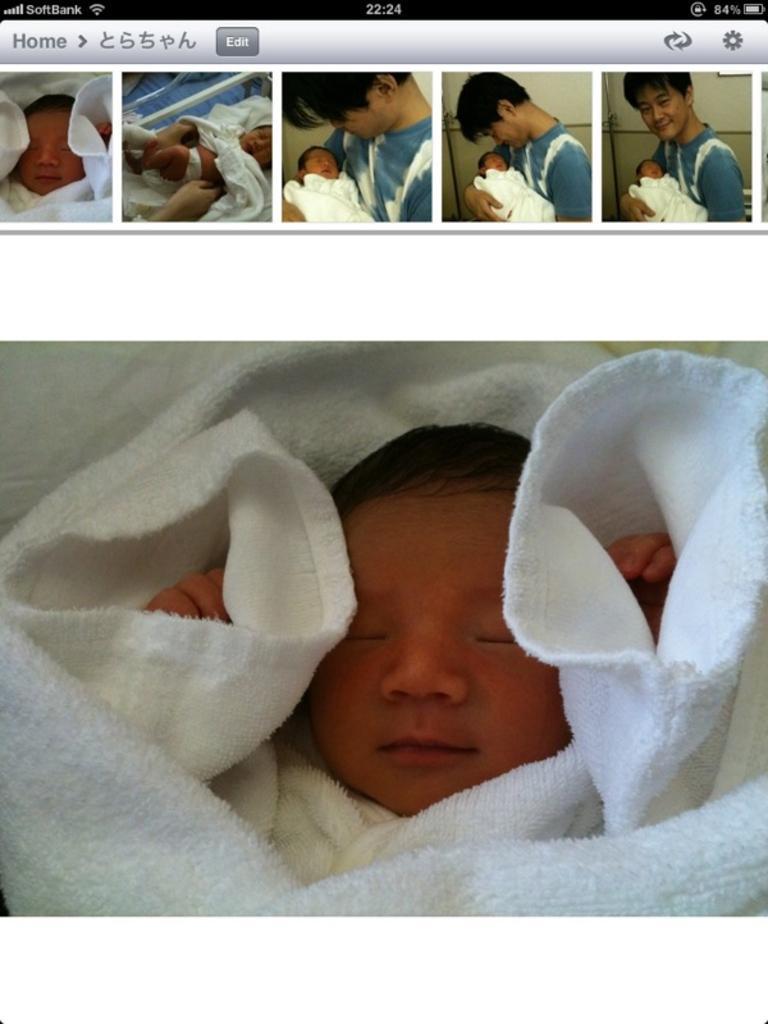How would you summarize this image in a sentence or two? In this picture we can see a screen screenshot of the mobile. In front there is a small baby sleeping in the white cloth. 